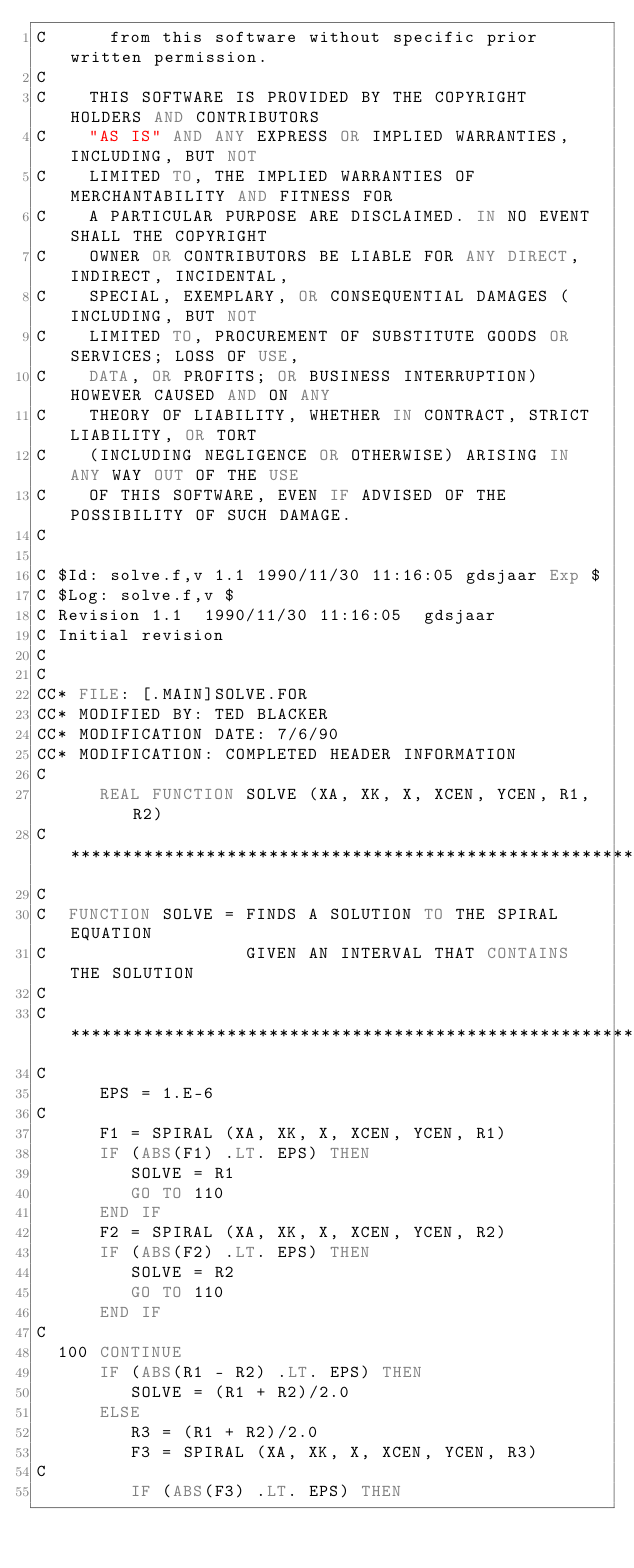Convert code to text. <code><loc_0><loc_0><loc_500><loc_500><_FORTRAN_>C      from this software without specific prior written permission.
C    
C    THIS SOFTWARE IS PROVIDED BY THE COPYRIGHT HOLDERS AND CONTRIBUTORS
C    "AS IS" AND ANY EXPRESS OR IMPLIED WARRANTIES, INCLUDING, BUT NOT
C    LIMITED TO, THE IMPLIED WARRANTIES OF MERCHANTABILITY AND FITNESS FOR
C    A PARTICULAR PURPOSE ARE DISCLAIMED. IN NO EVENT SHALL THE COPYRIGHT
C    OWNER OR CONTRIBUTORS BE LIABLE FOR ANY DIRECT, INDIRECT, INCIDENTAL,
C    SPECIAL, EXEMPLARY, OR CONSEQUENTIAL DAMAGES (INCLUDING, BUT NOT
C    LIMITED TO, PROCUREMENT OF SUBSTITUTE GOODS OR SERVICES; LOSS OF USE,
C    DATA, OR PROFITS; OR BUSINESS INTERRUPTION) HOWEVER CAUSED AND ON ANY
C    THEORY OF LIABILITY, WHETHER IN CONTRACT, STRICT LIABILITY, OR TORT
C    (INCLUDING NEGLIGENCE OR OTHERWISE) ARISING IN ANY WAY OUT OF THE USE
C    OF THIS SOFTWARE, EVEN IF ADVISED OF THE POSSIBILITY OF SUCH DAMAGE.
C    

C $Id: solve.f,v 1.1 1990/11/30 11:16:05 gdsjaar Exp $
C $Log: solve.f,v $
C Revision 1.1  1990/11/30 11:16:05  gdsjaar
C Initial revision
C
C
CC* FILE: [.MAIN]SOLVE.FOR
CC* MODIFIED BY: TED BLACKER
CC* MODIFICATION DATE: 7/6/90
CC* MODIFICATION: COMPLETED HEADER INFORMATION
C
      REAL FUNCTION SOLVE (XA, XK, X, XCEN, YCEN, R1, R2)
C***********************************************************************
C
C  FUNCTION SOLVE = FINDS A SOLUTION TO THE SPIRAL EQUATION
C                   GIVEN AN INTERVAL THAT CONTAINS THE SOLUTION
C
C***********************************************************************
C
      EPS = 1.E-6
C
      F1 = SPIRAL (XA, XK, X, XCEN, YCEN, R1)
      IF (ABS(F1) .LT. EPS) THEN
         SOLVE = R1
         GO TO 110
      END IF
      F2 = SPIRAL (XA, XK, X, XCEN, YCEN, R2)
      IF (ABS(F2) .LT. EPS) THEN
         SOLVE = R2
         GO TO 110
      END IF
C
  100 CONTINUE
      IF (ABS(R1 - R2) .LT. EPS) THEN
         SOLVE = (R1 + R2)/2.0
      ELSE
         R3 = (R1 + R2)/2.0
         F3 = SPIRAL (XA, XK, X, XCEN, YCEN, R3)
C
         IF (ABS(F3) .LT. EPS) THEN</code> 